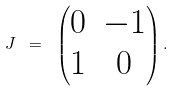Convert formula to latex. <formula><loc_0><loc_0><loc_500><loc_500>J \ = \ \begin{pmatrix} 0 & - 1 \\ 1 & 0 \end{pmatrix} .</formula> 